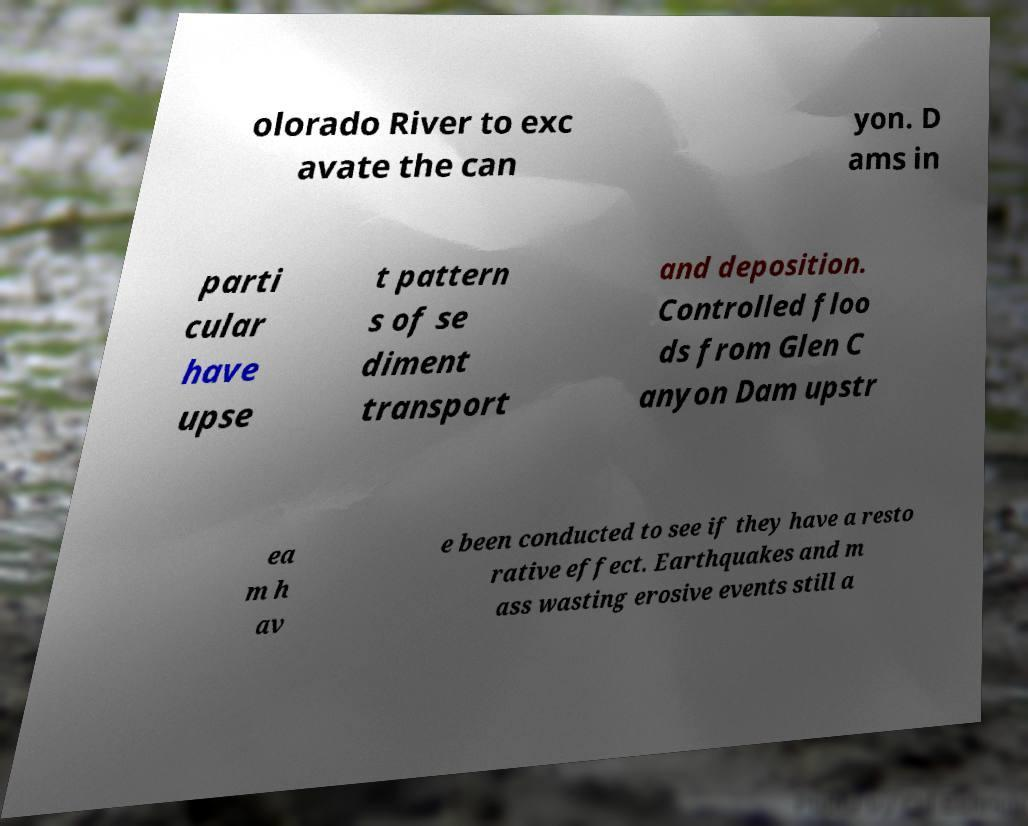Please read and relay the text visible in this image. What does it say? olorado River to exc avate the can yon. D ams in parti cular have upse t pattern s of se diment transport and deposition. Controlled floo ds from Glen C anyon Dam upstr ea m h av e been conducted to see if they have a resto rative effect. Earthquakes and m ass wasting erosive events still a 